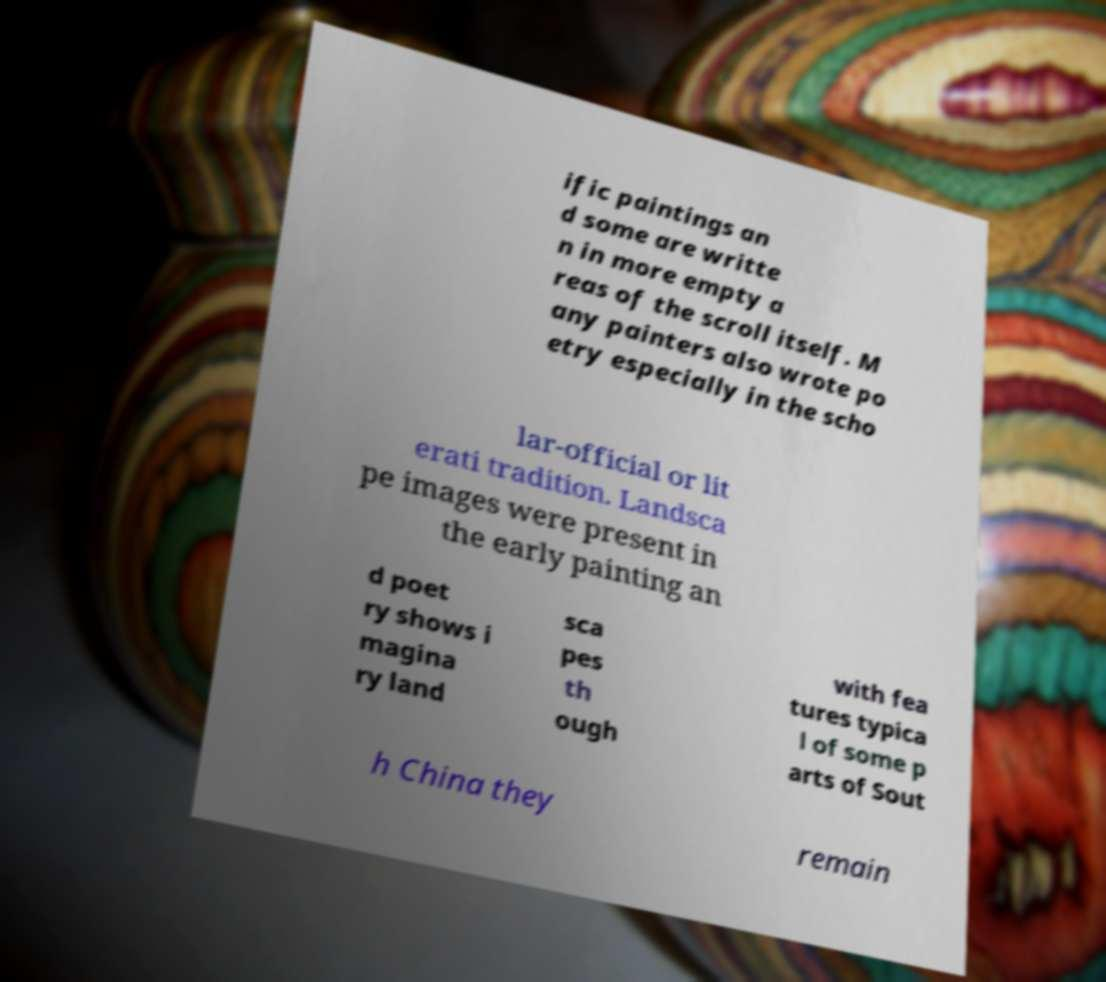Can you accurately transcribe the text from the provided image for me? ific paintings an d some are writte n in more empty a reas of the scroll itself. M any painters also wrote po etry especially in the scho lar-official or lit erati tradition. Landsca pe images were present in the early painting an d poet ry shows i magina ry land sca pes th ough with fea tures typica l of some p arts of Sout h China they remain 